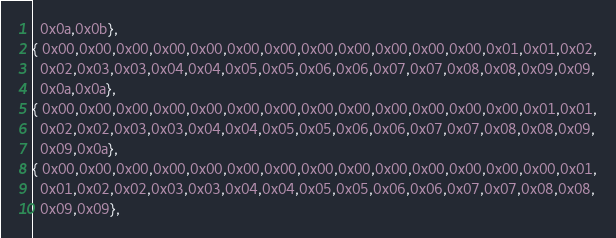Convert code to text. <code><loc_0><loc_0><loc_500><loc_500><_C++_>  0x0a,0x0b},
{ 0x00,0x00,0x00,0x00,0x00,0x00,0x00,0x00,0x00,0x00,0x00,0x00,0x01,0x01,0x02,
  0x02,0x03,0x03,0x04,0x04,0x05,0x05,0x06,0x06,0x07,0x07,0x08,0x08,0x09,0x09,
  0x0a,0x0a},
{ 0x00,0x00,0x00,0x00,0x00,0x00,0x00,0x00,0x00,0x00,0x00,0x00,0x00,0x01,0x01,
  0x02,0x02,0x03,0x03,0x04,0x04,0x05,0x05,0x06,0x06,0x07,0x07,0x08,0x08,0x09,
  0x09,0x0a},
{ 0x00,0x00,0x00,0x00,0x00,0x00,0x00,0x00,0x00,0x00,0x00,0x00,0x00,0x00,0x01,
  0x01,0x02,0x02,0x03,0x03,0x04,0x04,0x05,0x05,0x06,0x06,0x07,0x07,0x08,0x08,
  0x09,0x09},</code> 